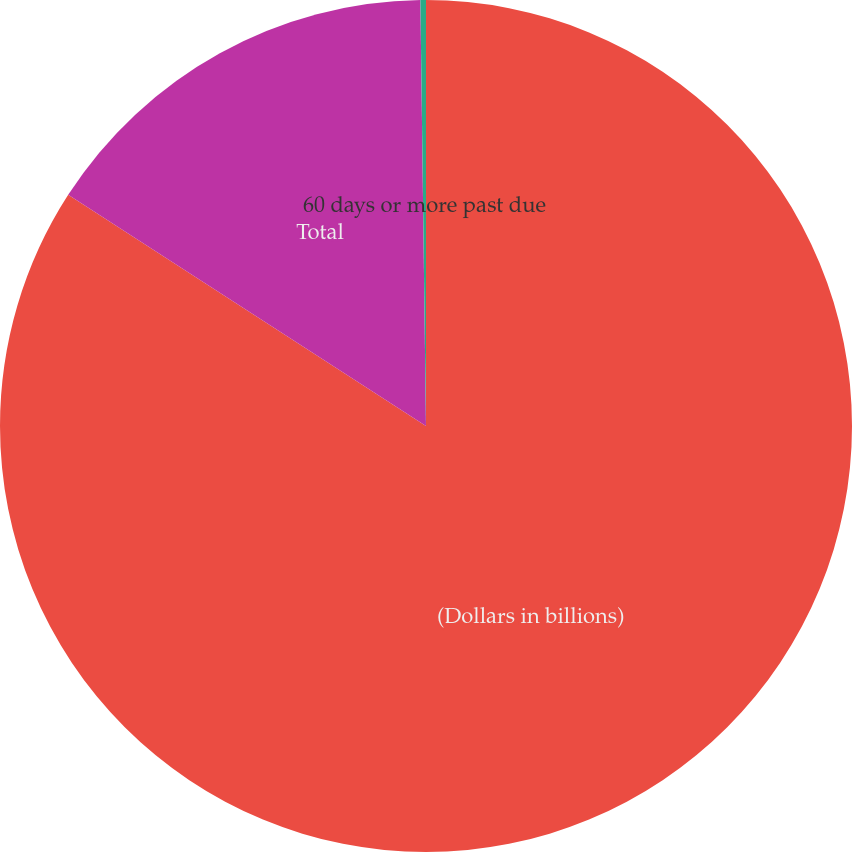<chart> <loc_0><loc_0><loc_500><loc_500><pie_chart><fcel>(Dollars in billions)<fcel>Total<fcel>60 days or more past due<nl><fcel>84.13%<fcel>15.66%<fcel>0.21%<nl></chart> 